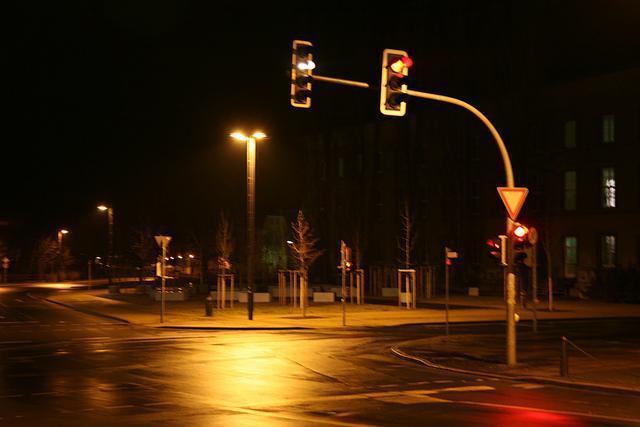How many cars are on the road?
Give a very brief answer. 0. 